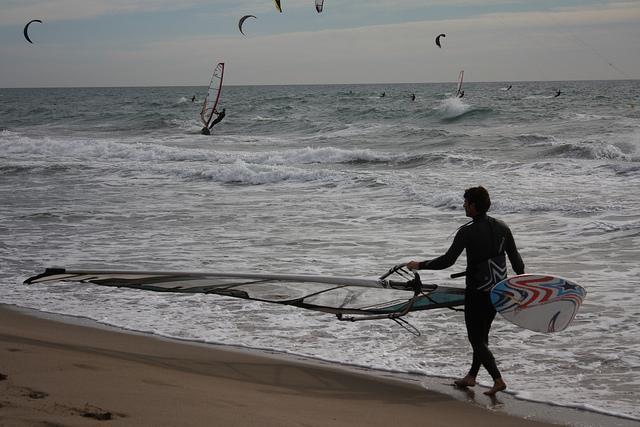What is the parachute called in paragliding?
Choose the correct response and explain in the format: 'Answer: answer
Rationale: rationale.'
Options: Canopy, wing, balloon, parachute. Answer: canopy.
Rationale: It kind of looks like a canopy. 